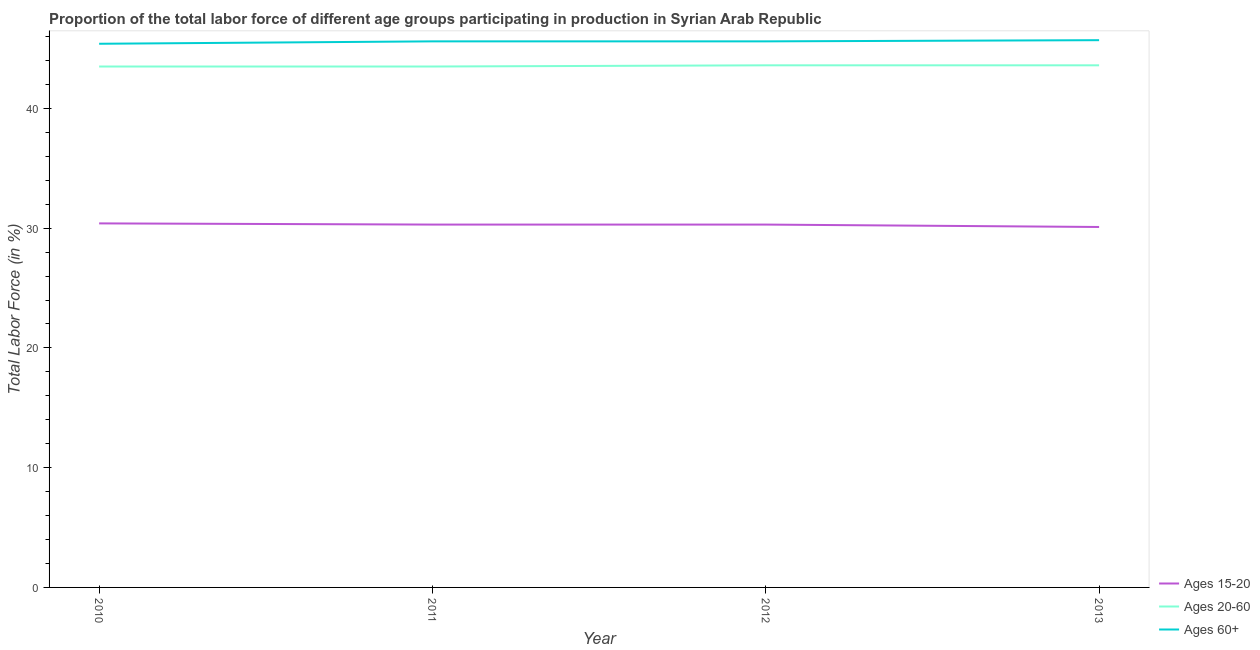How many different coloured lines are there?
Offer a very short reply. 3. Does the line corresponding to percentage of labor force above age 60 intersect with the line corresponding to percentage of labor force within the age group 20-60?
Ensure brevity in your answer.  No. What is the percentage of labor force within the age group 20-60 in 2011?
Offer a terse response. 43.5. Across all years, what is the maximum percentage of labor force above age 60?
Your response must be concise. 45.7. Across all years, what is the minimum percentage of labor force above age 60?
Your answer should be very brief. 45.4. In which year was the percentage of labor force within the age group 20-60 maximum?
Make the answer very short. 2012. What is the total percentage of labor force within the age group 15-20 in the graph?
Your answer should be very brief. 121.1. What is the average percentage of labor force above age 60 per year?
Offer a terse response. 45.57. In the year 2011, what is the difference between the percentage of labor force above age 60 and percentage of labor force within the age group 15-20?
Provide a succinct answer. 15.3. What is the ratio of the percentage of labor force above age 60 in 2010 to that in 2012?
Your answer should be compact. 1. What is the difference between the highest and the second highest percentage of labor force above age 60?
Offer a terse response. 0.1. What is the difference between the highest and the lowest percentage of labor force within the age group 20-60?
Keep it short and to the point. 0.1. Is it the case that in every year, the sum of the percentage of labor force within the age group 15-20 and percentage of labor force within the age group 20-60 is greater than the percentage of labor force above age 60?
Your answer should be compact. Yes. Is the percentage of labor force within the age group 20-60 strictly greater than the percentage of labor force above age 60 over the years?
Keep it short and to the point. No. Is the percentage of labor force above age 60 strictly less than the percentage of labor force within the age group 20-60 over the years?
Your answer should be very brief. No. How many years are there in the graph?
Make the answer very short. 4. What is the difference between two consecutive major ticks on the Y-axis?
Ensure brevity in your answer.  10. Does the graph contain any zero values?
Offer a very short reply. No. Where does the legend appear in the graph?
Ensure brevity in your answer.  Bottom right. How are the legend labels stacked?
Provide a succinct answer. Vertical. What is the title of the graph?
Offer a very short reply. Proportion of the total labor force of different age groups participating in production in Syrian Arab Republic. Does "Agriculture" appear as one of the legend labels in the graph?
Make the answer very short. No. What is the Total Labor Force (in %) in Ages 15-20 in 2010?
Your response must be concise. 30.4. What is the Total Labor Force (in %) of Ages 20-60 in 2010?
Make the answer very short. 43.5. What is the Total Labor Force (in %) in Ages 60+ in 2010?
Provide a succinct answer. 45.4. What is the Total Labor Force (in %) of Ages 15-20 in 2011?
Your response must be concise. 30.3. What is the Total Labor Force (in %) in Ages 20-60 in 2011?
Offer a very short reply. 43.5. What is the Total Labor Force (in %) in Ages 60+ in 2011?
Provide a succinct answer. 45.6. What is the Total Labor Force (in %) of Ages 15-20 in 2012?
Keep it short and to the point. 30.3. What is the Total Labor Force (in %) in Ages 20-60 in 2012?
Ensure brevity in your answer.  43.6. What is the Total Labor Force (in %) of Ages 60+ in 2012?
Provide a short and direct response. 45.6. What is the Total Labor Force (in %) in Ages 15-20 in 2013?
Provide a succinct answer. 30.1. What is the Total Labor Force (in %) in Ages 20-60 in 2013?
Make the answer very short. 43.6. What is the Total Labor Force (in %) of Ages 60+ in 2013?
Make the answer very short. 45.7. Across all years, what is the maximum Total Labor Force (in %) of Ages 15-20?
Make the answer very short. 30.4. Across all years, what is the maximum Total Labor Force (in %) of Ages 20-60?
Make the answer very short. 43.6. Across all years, what is the maximum Total Labor Force (in %) in Ages 60+?
Keep it short and to the point. 45.7. Across all years, what is the minimum Total Labor Force (in %) of Ages 15-20?
Keep it short and to the point. 30.1. Across all years, what is the minimum Total Labor Force (in %) of Ages 20-60?
Your response must be concise. 43.5. Across all years, what is the minimum Total Labor Force (in %) in Ages 60+?
Offer a very short reply. 45.4. What is the total Total Labor Force (in %) in Ages 15-20 in the graph?
Keep it short and to the point. 121.1. What is the total Total Labor Force (in %) in Ages 20-60 in the graph?
Ensure brevity in your answer.  174.2. What is the total Total Labor Force (in %) in Ages 60+ in the graph?
Offer a very short reply. 182.3. What is the difference between the Total Labor Force (in %) in Ages 60+ in 2010 and that in 2011?
Provide a succinct answer. -0.2. What is the difference between the Total Labor Force (in %) in Ages 15-20 in 2010 and that in 2012?
Your answer should be compact. 0.1. What is the difference between the Total Labor Force (in %) of Ages 60+ in 2010 and that in 2012?
Your response must be concise. -0.2. What is the difference between the Total Labor Force (in %) of Ages 20-60 in 2010 and that in 2013?
Keep it short and to the point. -0.1. What is the difference between the Total Labor Force (in %) in Ages 15-20 in 2011 and that in 2012?
Your response must be concise. 0. What is the difference between the Total Labor Force (in %) in Ages 20-60 in 2011 and that in 2012?
Keep it short and to the point. -0.1. What is the difference between the Total Labor Force (in %) in Ages 15-20 in 2011 and that in 2013?
Provide a short and direct response. 0.2. What is the difference between the Total Labor Force (in %) in Ages 20-60 in 2011 and that in 2013?
Make the answer very short. -0.1. What is the difference between the Total Labor Force (in %) of Ages 60+ in 2012 and that in 2013?
Offer a terse response. -0.1. What is the difference between the Total Labor Force (in %) in Ages 15-20 in 2010 and the Total Labor Force (in %) in Ages 60+ in 2011?
Give a very brief answer. -15.2. What is the difference between the Total Labor Force (in %) in Ages 20-60 in 2010 and the Total Labor Force (in %) in Ages 60+ in 2011?
Your answer should be compact. -2.1. What is the difference between the Total Labor Force (in %) of Ages 15-20 in 2010 and the Total Labor Force (in %) of Ages 60+ in 2012?
Provide a succinct answer. -15.2. What is the difference between the Total Labor Force (in %) in Ages 15-20 in 2010 and the Total Labor Force (in %) in Ages 20-60 in 2013?
Offer a terse response. -13.2. What is the difference between the Total Labor Force (in %) of Ages 15-20 in 2010 and the Total Labor Force (in %) of Ages 60+ in 2013?
Keep it short and to the point. -15.3. What is the difference between the Total Labor Force (in %) of Ages 20-60 in 2010 and the Total Labor Force (in %) of Ages 60+ in 2013?
Make the answer very short. -2.2. What is the difference between the Total Labor Force (in %) of Ages 15-20 in 2011 and the Total Labor Force (in %) of Ages 60+ in 2012?
Give a very brief answer. -15.3. What is the difference between the Total Labor Force (in %) in Ages 15-20 in 2011 and the Total Labor Force (in %) in Ages 60+ in 2013?
Make the answer very short. -15.4. What is the difference between the Total Labor Force (in %) in Ages 15-20 in 2012 and the Total Labor Force (in %) in Ages 60+ in 2013?
Your response must be concise. -15.4. What is the average Total Labor Force (in %) of Ages 15-20 per year?
Your answer should be compact. 30.27. What is the average Total Labor Force (in %) in Ages 20-60 per year?
Offer a very short reply. 43.55. What is the average Total Labor Force (in %) of Ages 60+ per year?
Your response must be concise. 45.58. In the year 2010, what is the difference between the Total Labor Force (in %) of Ages 15-20 and Total Labor Force (in %) of Ages 20-60?
Make the answer very short. -13.1. In the year 2010, what is the difference between the Total Labor Force (in %) in Ages 15-20 and Total Labor Force (in %) in Ages 60+?
Your answer should be very brief. -15. In the year 2010, what is the difference between the Total Labor Force (in %) of Ages 20-60 and Total Labor Force (in %) of Ages 60+?
Offer a very short reply. -1.9. In the year 2011, what is the difference between the Total Labor Force (in %) of Ages 15-20 and Total Labor Force (in %) of Ages 60+?
Offer a terse response. -15.3. In the year 2012, what is the difference between the Total Labor Force (in %) of Ages 15-20 and Total Labor Force (in %) of Ages 60+?
Your answer should be very brief. -15.3. In the year 2013, what is the difference between the Total Labor Force (in %) of Ages 15-20 and Total Labor Force (in %) of Ages 20-60?
Ensure brevity in your answer.  -13.5. In the year 2013, what is the difference between the Total Labor Force (in %) of Ages 15-20 and Total Labor Force (in %) of Ages 60+?
Offer a very short reply. -15.6. What is the ratio of the Total Labor Force (in %) of Ages 15-20 in 2010 to that in 2011?
Your response must be concise. 1. What is the ratio of the Total Labor Force (in %) in Ages 60+ in 2010 to that in 2011?
Your answer should be compact. 1. What is the ratio of the Total Labor Force (in %) of Ages 15-20 in 2010 to that in 2012?
Provide a succinct answer. 1. What is the ratio of the Total Labor Force (in %) in Ages 15-20 in 2010 to that in 2013?
Your answer should be compact. 1.01. What is the ratio of the Total Labor Force (in %) in Ages 60+ in 2011 to that in 2012?
Offer a very short reply. 1. What is the ratio of the Total Labor Force (in %) of Ages 15-20 in 2011 to that in 2013?
Offer a terse response. 1.01. What is the ratio of the Total Labor Force (in %) in Ages 15-20 in 2012 to that in 2013?
Offer a terse response. 1.01. What is the ratio of the Total Labor Force (in %) in Ages 60+ in 2012 to that in 2013?
Offer a terse response. 1. What is the difference between the highest and the second highest Total Labor Force (in %) in Ages 15-20?
Offer a very short reply. 0.1. What is the difference between the highest and the second highest Total Labor Force (in %) of Ages 20-60?
Make the answer very short. 0. What is the difference between the highest and the second highest Total Labor Force (in %) of Ages 60+?
Your answer should be compact. 0.1. What is the difference between the highest and the lowest Total Labor Force (in %) in Ages 15-20?
Provide a short and direct response. 0.3. 